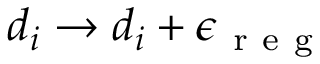<formula> <loc_0><loc_0><loc_500><loc_500>d _ { i } \to d _ { i } + \epsilon _ { r e g }</formula> 